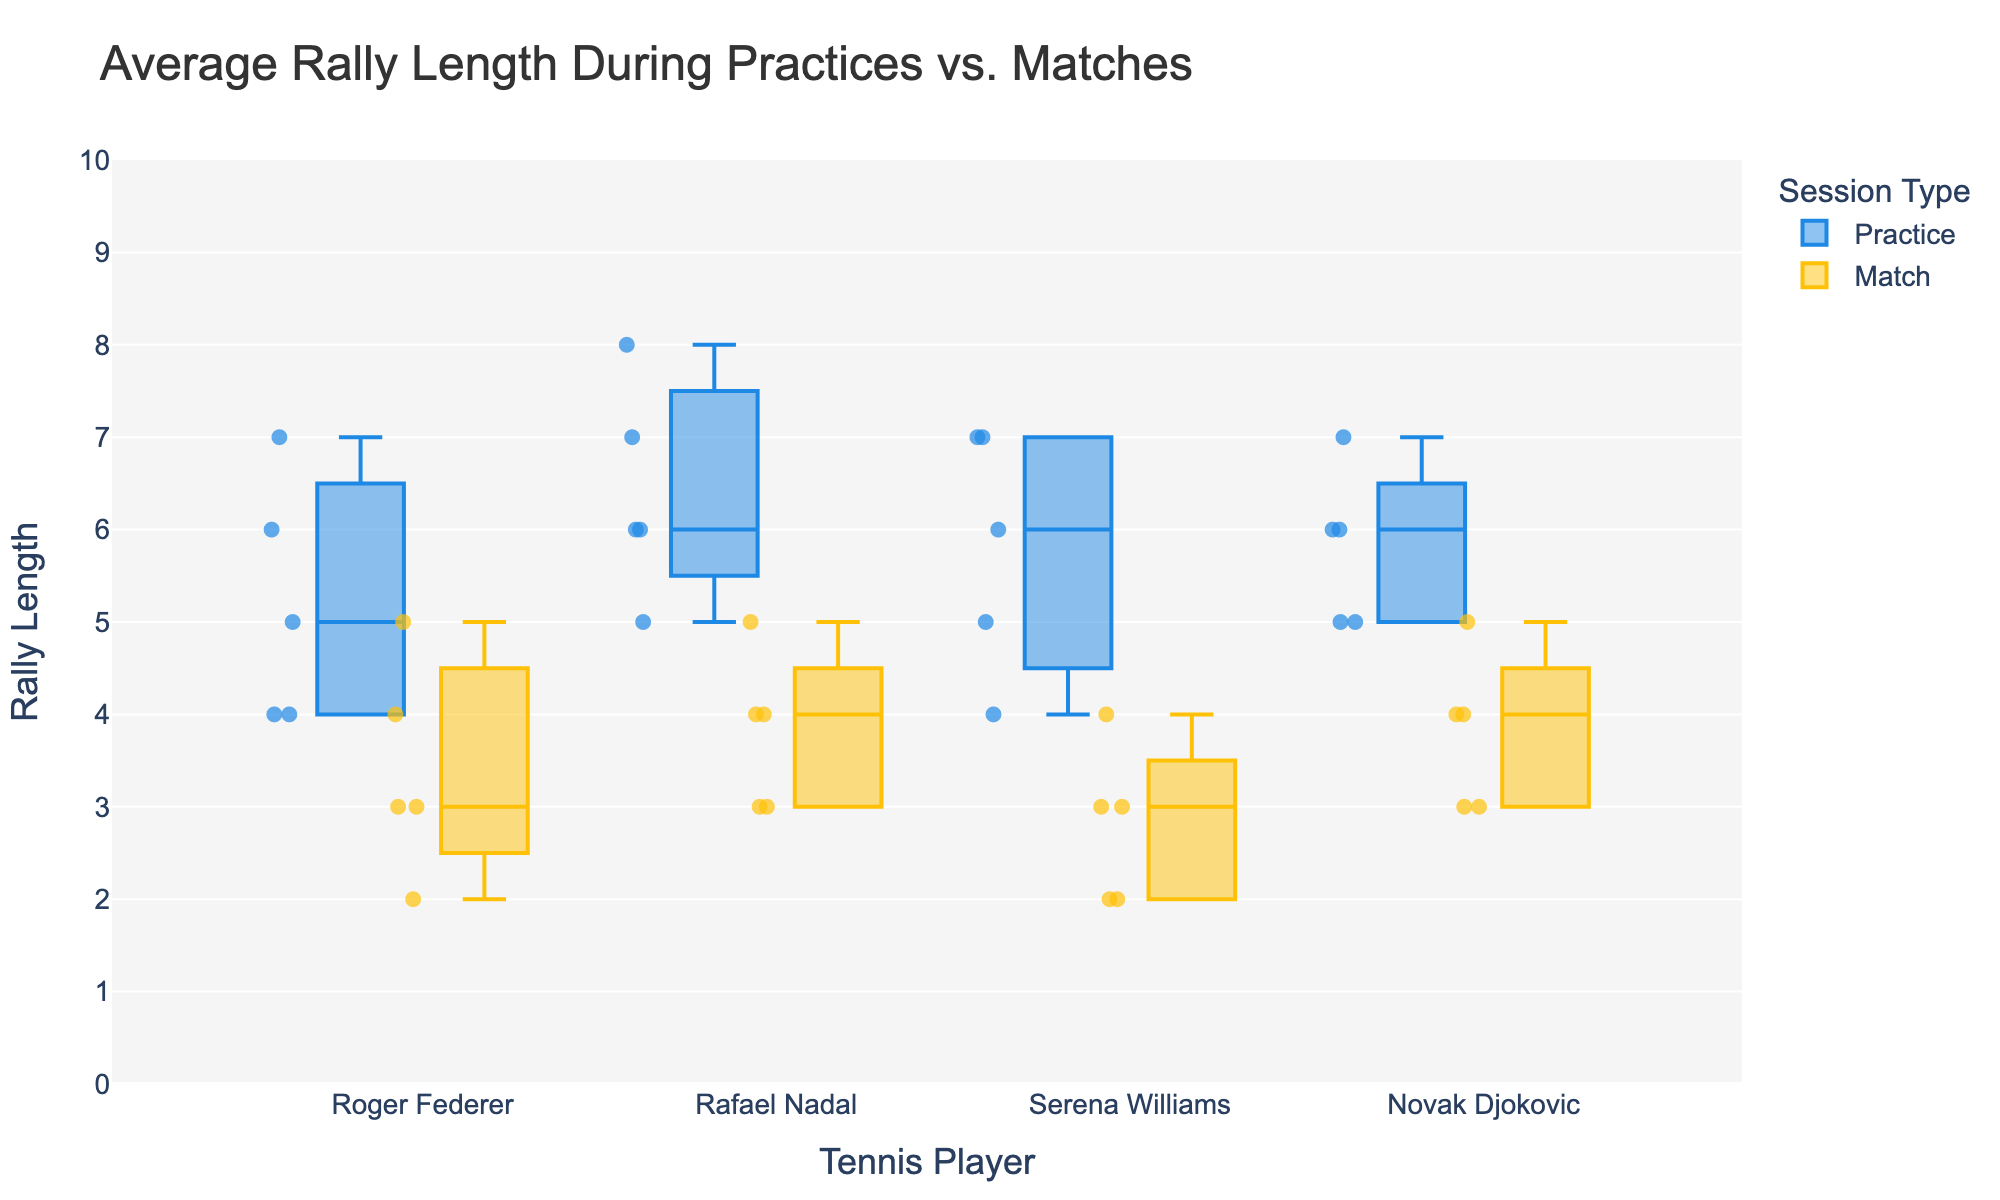What is the title of the plot? The title is displayed at the top of the plot, it is explicitly stated in larger font.
Answer: Average Rally Length During Practices vs. Matches What session type is marked by the yellowish color? The color legend indicates which session type corresponds to which color. The yellowish color corresponds to the label 'Match'.
Answer: Match How many different players are visualized in the plot? The x-axis lists the names of the players, counting these names will give the number.
Answer: 4 Which player has the highest median rally length during practice? For each player, identify the median line within the Practice box plot. The player with the highest median line in the Practice category is the answer.
Answer: Rafael Nadal What is the range of rally lengths for Serena Williams during matches? Look at the Serena Williams' box for matches. The range is defined by the minimum and maximum whiskers.
Answer: 2 to 4 Who shows more consistency in rally lengths during matches, Roger Federer or Novak Djokovic? Consistency can be inferred from the spread of the data points in their match boxes. A smaller spread (whiskers closer together) indicates more consistency.
Answer: Novak Djokovic What is the interquartile range (IQR) for Rafael Nadal during practice? The IQR is the distance between the first quartile (bottom of the box) and third quartile (top of the box) in Rafael Nadal's practice box.
Answer: 6 to 7 Which player has the most similar rally lengths in both practice and matches? Compare the box plots of practice and matches for each player. Similar box sizes and ranges for both session types for a player indicate similar rally lengths.
Answer: Roger Federer How does Serena Williams' performance differ during practice as compared to matches? Compare the positions of the practice and match boxes for Serena Williams. Analyze the median, range, and outliers between the two types.
Answer: Longer rallies in practice than in matches Which player’s performance shows the greatest change from practice to matches? Look for the player with the largest difference in median lines or the spread between the practice and match boxes.
Answer: Rafael Nadal 